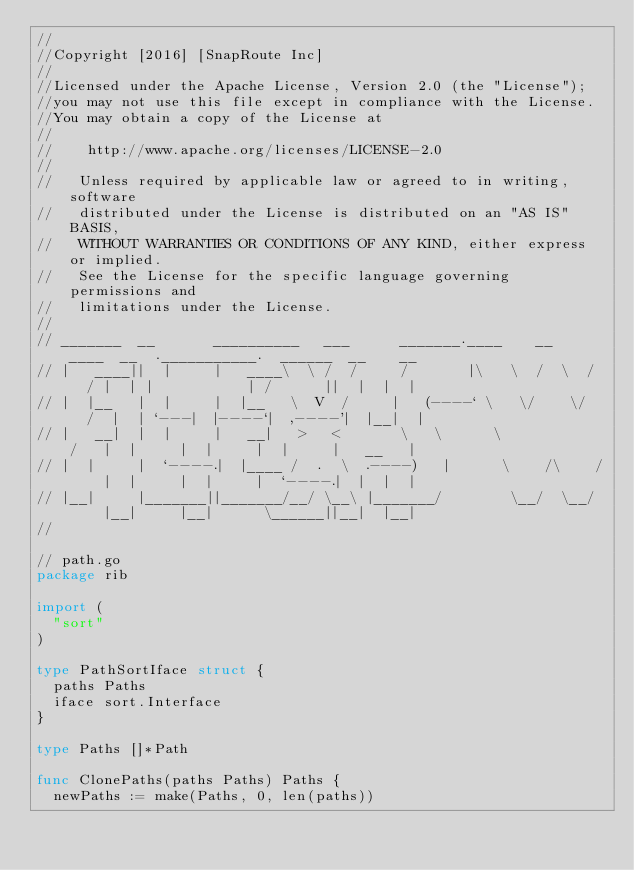Convert code to text. <code><loc_0><loc_0><loc_500><loc_500><_Go_>//
//Copyright [2016] [SnapRoute Inc]
//
//Licensed under the Apache License, Version 2.0 (the "License");
//you may not use this file except in compliance with the License.
//You may obtain a copy of the License at
//
//    http://www.apache.org/licenses/LICENSE-2.0
//
//	 Unless required by applicable law or agreed to in writing, software
//	 distributed under the License is distributed on an "AS IS" BASIS,
//	 WITHOUT WARRANTIES OR CONDITIONS OF ANY KIND, either express or implied.
//	 See the License for the specific language governing permissions and
//	 limitations under the License.
//
// _______  __       __________   ___      _______.____    __    ____  __  .___________.  ______  __    __
// |   ____||  |     |   ____\  \ /  /     /       |\   \  /  \  /   / |  | |           | /      ||  |  |  |
// |  |__   |  |     |  |__   \  V  /     |   (----` \   \/    \/   /  |  | `---|  |----`|  ,----'|  |__|  |
// |   __|  |  |     |   __|   >   <       \   \      \            /   |  |     |  |     |  |     |   __   |
// |  |     |  `----.|  |____ /  .  \  .----)   |      \    /\    /    |  |     |  |     |  `----.|  |  |  |
// |__|     |_______||_______/__/ \__\ |_______/        \__/  \__/     |__|     |__|      \______||__|  |__|
//

// path.go
package rib

import (
	"sort"
)

type PathSortIface struct {
	paths Paths
	iface sort.Interface
}

type Paths []*Path

func ClonePaths(paths Paths) Paths {
	newPaths := make(Paths, 0, len(paths))</code> 